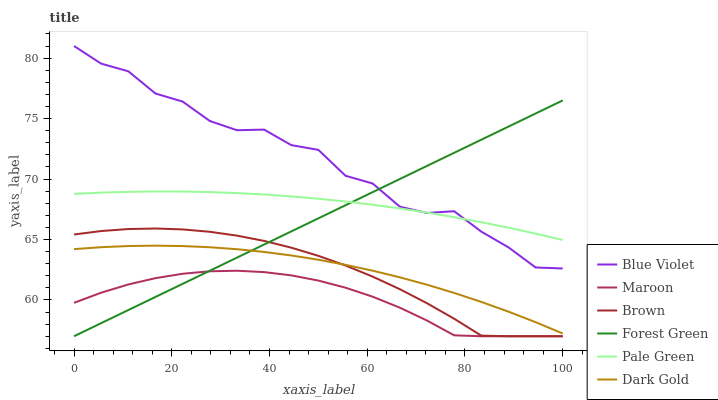Does Maroon have the minimum area under the curve?
Answer yes or no. Yes. Does Blue Violet have the maximum area under the curve?
Answer yes or no. Yes. Does Dark Gold have the minimum area under the curve?
Answer yes or no. No. Does Dark Gold have the maximum area under the curve?
Answer yes or no. No. Is Forest Green the smoothest?
Answer yes or no. Yes. Is Blue Violet the roughest?
Answer yes or no. Yes. Is Dark Gold the smoothest?
Answer yes or no. No. Is Dark Gold the roughest?
Answer yes or no. No. Does Brown have the lowest value?
Answer yes or no. Yes. Does Dark Gold have the lowest value?
Answer yes or no. No. Does Blue Violet have the highest value?
Answer yes or no. Yes. Does Dark Gold have the highest value?
Answer yes or no. No. Is Maroon less than Pale Green?
Answer yes or no. Yes. Is Pale Green greater than Brown?
Answer yes or no. Yes. Does Maroon intersect Brown?
Answer yes or no. Yes. Is Maroon less than Brown?
Answer yes or no. No. Is Maroon greater than Brown?
Answer yes or no. No. Does Maroon intersect Pale Green?
Answer yes or no. No. 